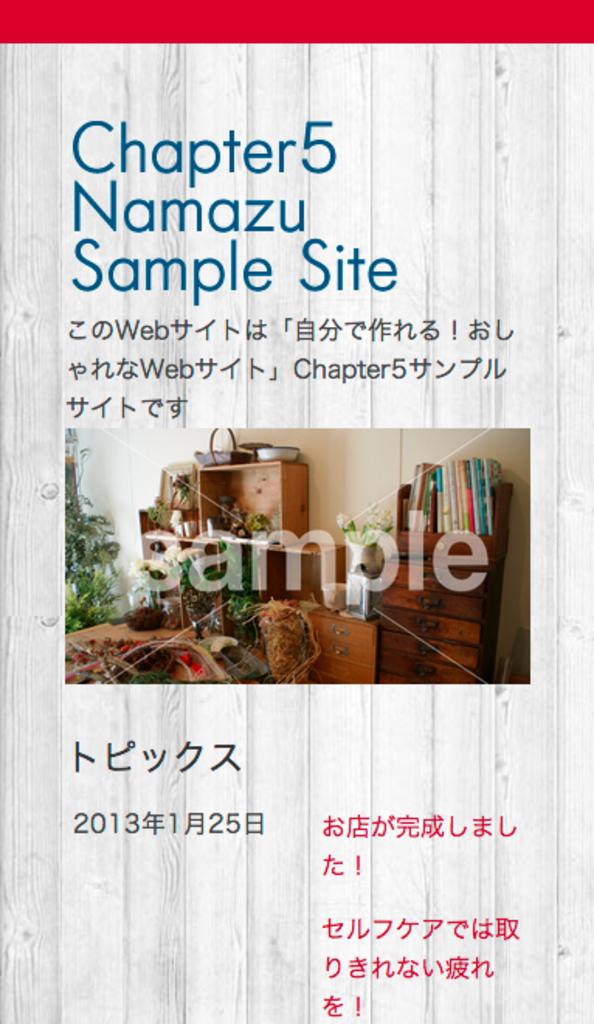What chapter is this?
Keep it short and to the point. 5. What kind of site is this?
Provide a succinct answer. Sample. 